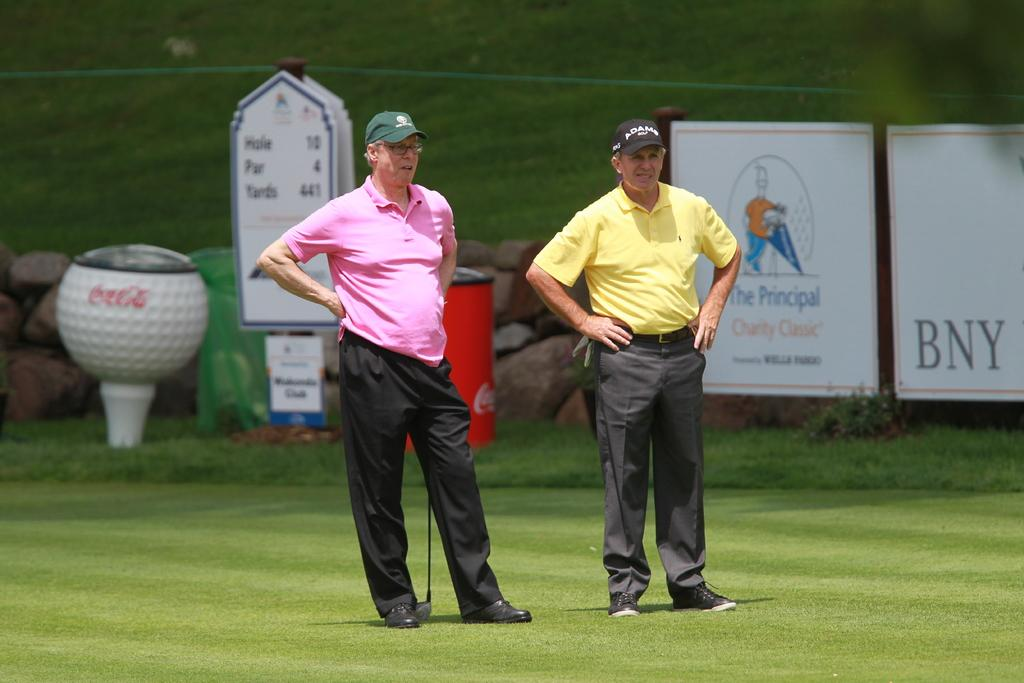<image>
Give a short and clear explanation of the subsequent image. Two men standing on a golf course that has a sign for The Principal Charity Classic sponsored by Wells Fargo. 